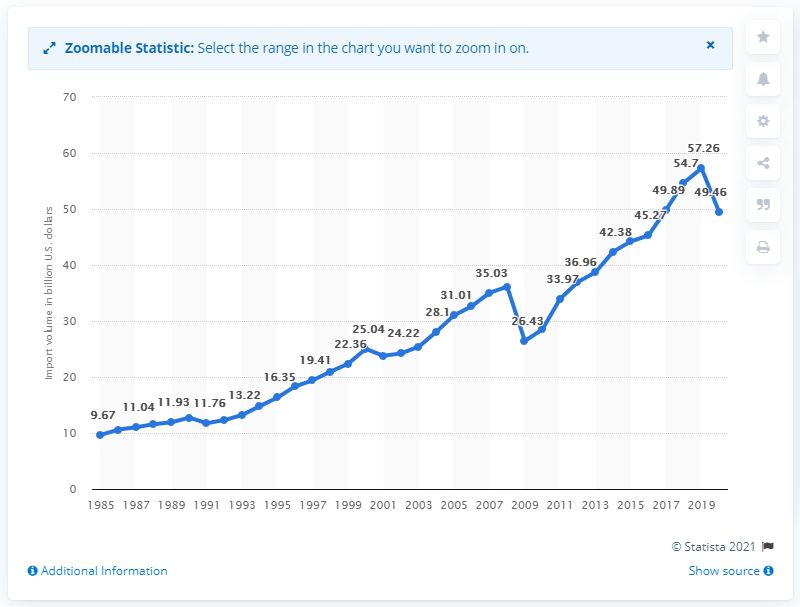Specify some key components in this picture. In 2020, the value of imports from Italy in dollars was 49.46.... 